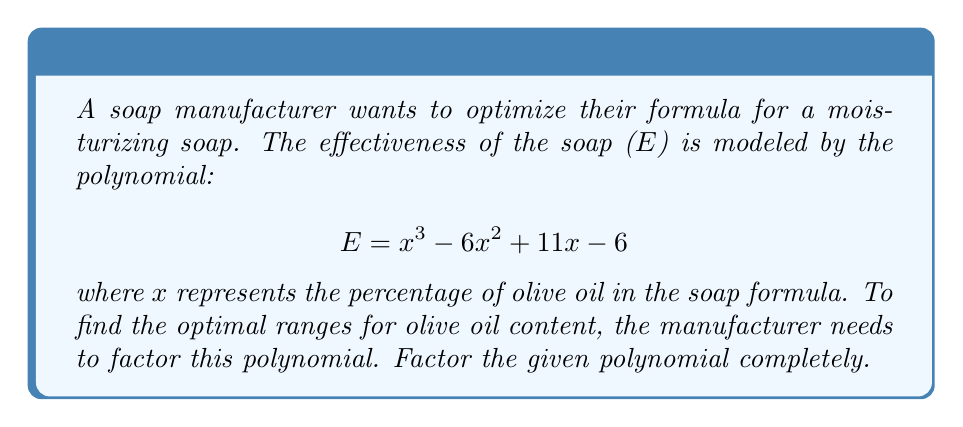Solve this math problem. To factor this polynomial, we'll follow these steps:

1) First, let's check if there are any rational roots using the rational root theorem. The possible rational roots are the factors of the constant term: ±1, ±2, ±3, ±6.

2) Testing these values, we find that x = 1 is a root. So (x - 1) is a factor.

3) We can use polynomial long division to divide the original polynomial by (x - 1):

$$ \frac{x^3 - 6x^2 + 11x - 6}{x - 1} = x^2 - 5x + 6 $$

4) Now we have: $E = (x - 1)(x^2 - 5x + 6)$

5) The quadratic factor $x^2 - 5x + 6$ can be factored further:
   
   $x^2 - 5x + 6 = (x - 2)(x - 3)$

6) Therefore, the complete factorization is:

$$ E = (x - 1)(x - 2)(x - 3) $$

This factorization shows that the effectiveness function has roots at x = 1, x = 2, and x = 3, corresponding to 1%, 2%, and 3% olive oil content respectively.
Answer: $$ E = (x - 1)(x - 2)(x - 3) $$ 